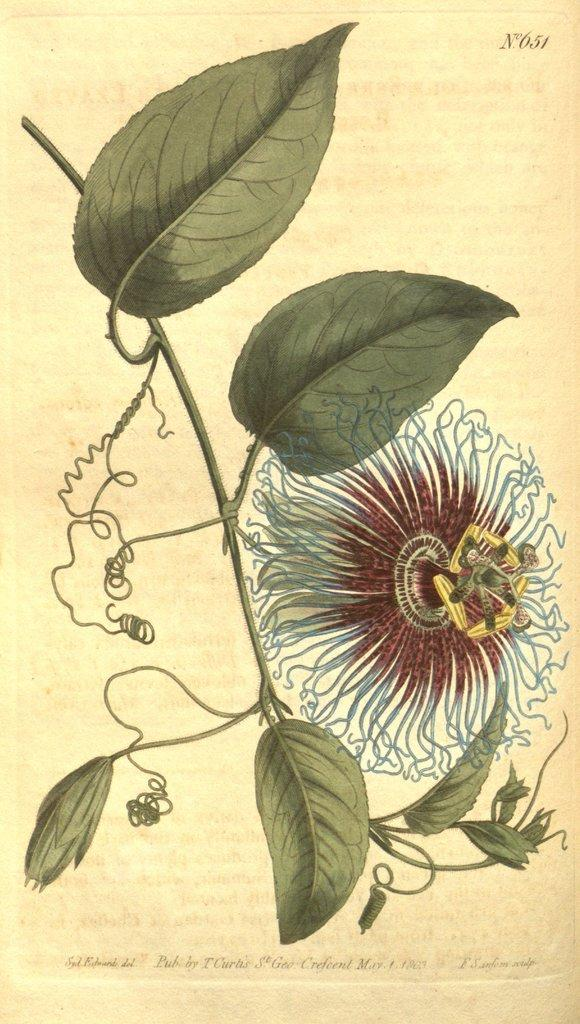What is featured on the poster in the image? The poster includes images of flowers and leaves. Is there any text on the poster? Yes, there is text at the bottom of the poster. How many fingers can be seen crushing the flowers in the image? There are no fingers or any indication of crushing in the image; it features a poster with images of flowers and leaves, along with text at the bottom. 